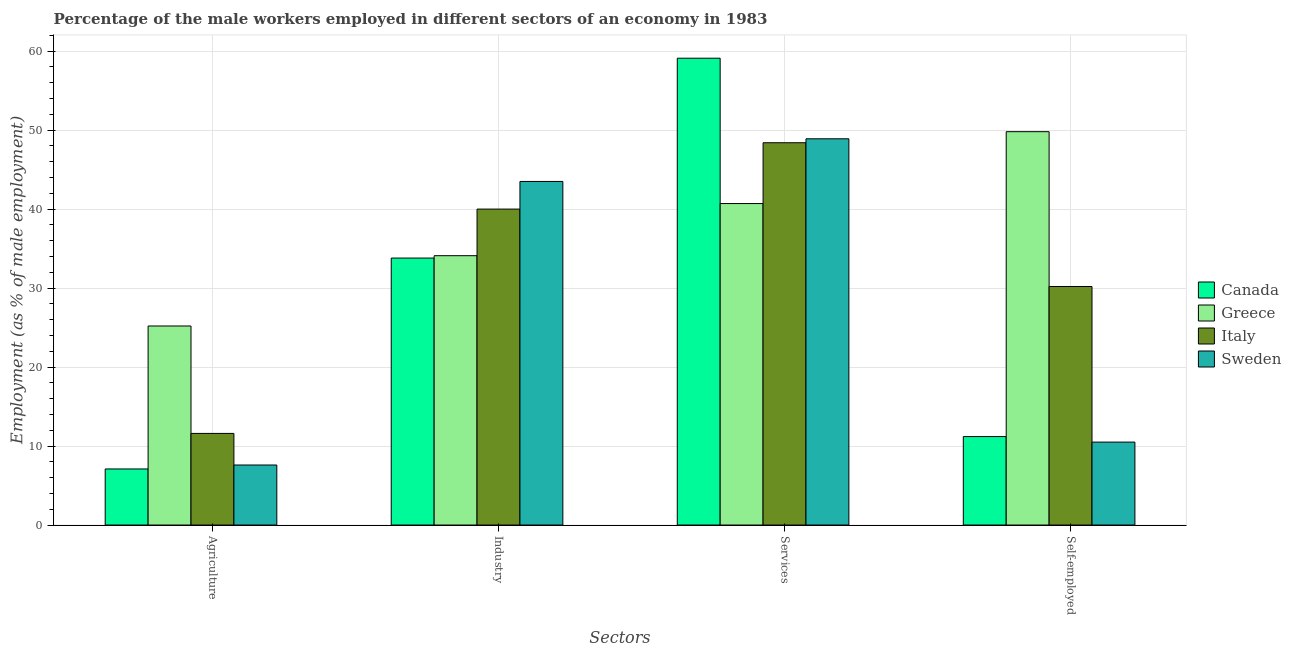How many different coloured bars are there?
Keep it short and to the point. 4. How many groups of bars are there?
Your answer should be very brief. 4. Are the number of bars per tick equal to the number of legend labels?
Offer a terse response. Yes. Are the number of bars on each tick of the X-axis equal?
Make the answer very short. Yes. What is the label of the 4th group of bars from the left?
Provide a succinct answer. Self-employed. What is the percentage of self employed male workers in Canada?
Keep it short and to the point. 11.2. Across all countries, what is the maximum percentage of male workers in agriculture?
Provide a short and direct response. 25.2. Across all countries, what is the minimum percentage of self employed male workers?
Your answer should be very brief. 10.5. In which country was the percentage of male workers in agriculture maximum?
Your response must be concise. Greece. In which country was the percentage of male workers in services minimum?
Offer a terse response. Greece. What is the total percentage of male workers in services in the graph?
Provide a succinct answer. 197.1. What is the difference between the percentage of male workers in industry in Sweden and that in Greece?
Make the answer very short. 9.4. What is the difference between the percentage of male workers in services in Canada and the percentage of male workers in industry in Italy?
Offer a terse response. 19.1. What is the average percentage of male workers in industry per country?
Your answer should be compact. 37.85. What is the difference between the percentage of male workers in industry and percentage of male workers in services in Sweden?
Ensure brevity in your answer.  -5.4. In how many countries, is the percentage of male workers in industry greater than 60 %?
Make the answer very short. 0. What is the ratio of the percentage of male workers in industry in Italy to that in Greece?
Offer a very short reply. 1.17. Is the percentage of male workers in industry in Italy less than that in Canada?
Your answer should be compact. No. Is the difference between the percentage of male workers in industry in Canada and Sweden greater than the difference between the percentage of self employed male workers in Canada and Sweden?
Give a very brief answer. No. What is the difference between the highest and the second highest percentage of self employed male workers?
Ensure brevity in your answer.  19.6. What is the difference between the highest and the lowest percentage of male workers in agriculture?
Offer a terse response. 18.1. In how many countries, is the percentage of self employed male workers greater than the average percentage of self employed male workers taken over all countries?
Offer a very short reply. 2. Is the sum of the percentage of male workers in services in Italy and Sweden greater than the maximum percentage of male workers in agriculture across all countries?
Keep it short and to the point. Yes. Is it the case that in every country, the sum of the percentage of male workers in industry and percentage of self employed male workers is greater than the sum of percentage of male workers in services and percentage of male workers in agriculture?
Your answer should be compact. Yes. Are all the bars in the graph horizontal?
Offer a terse response. No. How many countries are there in the graph?
Your answer should be compact. 4. Does the graph contain any zero values?
Your answer should be very brief. No. Does the graph contain grids?
Your answer should be compact. Yes. How many legend labels are there?
Ensure brevity in your answer.  4. What is the title of the graph?
Ensure brevity in your answer.  Percentage of the male workers employed in different sectors of an economy in 1983. Does "Maldives" appear as one of the legend labels in the graph?
Provide a short and direct response. No. What is the label or title of the X-axis?
Provide a short and direct response. Sectors. What is the label or title of the Y-axis?
Ensure brevity in your answer.  Employment (as % of male employment). What is the Employment (as % of male employment) in Canada in Agriculture?
Keep it short and to the point. 7.1. What is the Employment (as % of male employment) of Greece in Agriculture?
Provide a short and direct response. 25.2. What is the Employment (as % of male employment) in Italy in Agriculture?
Make the answer very short. 11.6. What is the Employment (as % of male employment) of Sweden in Agriculture?
Provide a short and direct response. 7.6. What is the Employment (as % of male employment) of Canada in Industry?
Your response must be concise. 33.8. What is the Employment (as % of male employment) of Greece in Industry?
Offer a very short reply. 34.1. What is the Employment (as % of male employment) in Sweden in Industry?
Your answer should be compact. 43.5. What is the Employment (as % of male employment) of Canada in Services?
Your response must be concise. 59.1. What is the Employment (as % of male employment) in Greece in Services?
Make the answer very short. 40.7. What is the Employment (as % of male employment) of Italy in Services?
Provide a short and direct response. 48.4. What is the Employment (as % of male employment) of Sweden in Services?
Offer a terse response. 48.9. What is the Employment (as % of male employment) in Canada in Self-employed?
Ensure brevity in your answer.  11.2. What is the Employment (as % of male employment) in Greece in Self-employed?
Provide a succinct answer. 49.8. What is the Employment (as % of male employment) in Italy in Self-employed?
Your answer should be compact. 30.2. What is the Employment (as % of male employment) of Sweden in Self-employed?
Give a very brief answer. 10.5. Across all Sectors, what is the maximum Employment (as % of male employment) of Canada?
Your response must be concise. 59.1. Across all Sectors, what is the maximum Employment (as % of male employment) in Greece?
Your response must be concise. 49.8. Across all Sectors, what is the maximum Employment (as % of male employment) of Italy?
Your answer should be compact. 48.4. Across all Sectors, what is the maximum Employment (as % of male employment) of Sweden?
Offer a very short reply. 48.9. Across all Sectors, what is the minimum Employment (as % of male employment) of Canada?
Your answer should be compact. 7.1. Across all Sectors, what is the minimum Employment (as % of male employment) of Greece?
Keep it short and to the point. 25.2. Across all Sectors, what is the minimum Employment (as % of male employment) of Italy?
Give a very brief answer. 11.6. Across all Sectors, what is the minimum Employment (as % of male employment) in Sweden?
Your answer should be very brief. 7.6. What is the total Employment (as % of male employment) of Canada in the graph?
Ensure brevity in your answer.  111.2. What is the total Employment (as % of male employment) of Greece in the graph?
Your answer should be compact. 149.8. What is the total Employment (as % of male employment) in Italy in the graph?
Ensure brevity in your answer.  130.2. What is the total Employment (as % of male employment) of Sweden in the graph?
Offer a very short reply. 110.5. What is the difference between the Employment (as % of male employment) of Canada in Agriculture and that in Industry?
Your response must be concise. -26.7. What is the difference between the Employment (as % of male employment) in Italy in Agriculture and that in Industry?
Make the answer very short. -28.4. What is the difference between the Employment (as % of male employment) in Sweden in Agriculture and that in Industry?
Your answer should be compact. -35.9. What is the difference between the Employment (as % of male employment) in Canada in Agriculture and that in Services?
Provide a short and direct response. -52. What is the difference between the Employment (as % of male employment) in Greece in Agriculture and that in Services?
Ensure brevity in your answer.  -15.5. What is the difference between the Employment (as % of male employment) in Italy in Agriculture and that in Services?
Your answer should be very brief. -36.8. What is the difference between the Employment (as % of male employment) of Sweden in Agriculture and that in Services?
Your answer should be compact. -41.3. What is the difference between the Employment (as % of male employment) of Greece in Agriculture and that in Self-employed?
Keep it short and to the point. -24.6. What is the difference between the Employment (as % of male employment) of Italy in Agriculture and that in Self-employed?
Your answer should be very brief. -18.6. What is the difference between the Employment (as % of male employment) in Canada in Industry and that in Services?
Your response must be concise. -25.3. What is the difference between the Employment (as % of male employment) in Greece in Industry and that in Services?
Provide a short and direct response. -6.6. What is the difference between the Employment (as % of male employment) in Canada in Industry and that in Self-employed?
Give a very brief answer. 22.6. What is the difference between the Employment (as % of male employment) of Greece in Industry and that in Self-employed?
Your response must be concise. -15.7. What is the difference between the Employment (as % of male employment) of Italy in Industry and that in Self-employed?
Ensure brevity in your answer.  9.8. What is the difference between the Employment (as % of male employment) in Sweden in Industry and that in Self-employed?
Your response must be concise. 33. What is the difference between the Employment (as % of male employment) in Canada in Services and that in Self-employed?
Offer a very short reply. 47.9. What is the difference between the Employment (as % of male employment) of Italy in Services and that in Self-employed?
Make the answer very short. 18.2. What is the difference between the Employment (as % of male employment) in Sweden in Services and that in Self-employed?
Keep it short and to the point. 38.4. What is the difference between the Employment (as % of male employment) of Canada in Agriculture and the Employment (as % of male employment) of Italy in Industry?
Ensure brevity in your answer.  -32.9. What is the difference between the Employment (as % of male employment) of Canada in Agriculture and the Employment (as % of male employment) of Sweden in Industry?
Provide a succinct answer. -36.4. What is the difference between the Employment (as % of male employment) in Greece in Agriculture and the Employment (as % of male employment) in Italy in Industry?
Ensure brevity in your answer.  -14.8. What is the difference between the Employment (as % of male employment) in Greece in Agriculture and the Employment (as % of male employment) in Sweden in Industry?
Provide a succinct answer. -18.3. What is the difference between the Employment (as % of male employment) in Italy in Agriculture and the Employment (as % of male employment) in Sweden in Industry?
Your response must be concise. -31.9. What is the difference between the Employment (as % of male employment) of Canada in Agriculture and the Employment (as % of male employment) of Greece in Services?
Offer a very short reply. -33.6. What is the difference between the Employment (as % of male employment) of Canada in Agriculture and the Employment (as % of male employment) of Italy in Services?
Offer a very short reply. -41.3. What is the difference between the Employment (as % of male employment) of Canada in Agriculture and the Employment (as % of male employment) of Sweden in Services?
Offer a terse response. -41.8. What is the difference between the Employment (as % of male employment) in Greece in Agriculture and the Employment (as % of male employment) in Italy in Services?
Your response must be concise. -23.2. What is the difference between the Employment (as % of male employment) in Greece in Agriculture and the Employment (as % of male employment) in Sweden in Services?
Your answer should be very brief. -23.7. What is the difference between the Employment (as % of male employment) of Italy in Agriculture and the Employment (as % of male employment) of Sweden in Services?
Offer a very short reply. -37.3. What is the difference between the Employment (as % of male employment) of Canada in Agriculture and the Employment (as % of male employment) of Greece in Self-employed?
Offer a very short reply. -42.7. What is the difference between the Employment (as % of male employment) in Canada in Agriculture and the Employment (as % of male employment) in Italy in Self-employed?
Ensure brevity in your answer.  -23.1. What is the difference between the Employment (as % of male employment) of Canada in Industry and the Employment (as % of male employment) of Greece in Services?
Your answer should be compact. -6.9. What is the difference between the Employment (as % of male employment) in Canada in Industry and the Employment (as % of male employment) in Italy in Services?
Keep it short and to the point. -14.6. What is the difference between the Employment (as % of male employment) of Canada in Industry and the Employment (as % of male employment) of Sweden in Services?
Keep it short and to the point. -15.1. What is the difference between the Employment (as % of male employment) of Greece in Industry and the Employment (as % of male employment) of Italy in Services?
Keep it short and to the point. -14.3. What is the difference between the Employment (as % of male employment) in Greece in Industry and the Employment (as % of male employment) in Sweden in Services?
Your answer should be compact. -14.8. What is the difference between the Employment (as % of male employment) in Italy in Industry and the Employment (as % of male employment) in Sweden in Services?
Offer a terse response. -8.9. What is the difference between the Employment (as % of male employment) in Canada in Industry and the Employment (as % of male employment) in Greece in Self-employed?
Offer a terse response. -16. What is the difference between the Employment (as % of male employment) in Canada in Industry and the Employment (as % of male employment) in Sweden in Self-employed?
Your response must be concise. 23.3. What is the difference between the Employment (as % of male employment) of Greece in Industry and the Employment (as % of male employment) of Italy in Self-employed?
Give a very brief answer. 3.9. What is the difference between the Employment (as % of male employment) of Greece in Industry and the Employment (as % of male employment) of Sweden in Self-employed?
Keep it short and to the point. 23.6. What is the difference between the Employment (as % of male employment) of Italy in Industry and the Employment (as % of male employment) of Sweden in Self-employed?
Your answer should be compact. 29.5. What is the difference between the Employment (as % of male employment) of Canada in Services and the Employment (as % of male employment) of Italy in Self-employed?
Keep it short and to the point. 28.9. What is the difference between the Employment (as % of male employment) in Canada in Services and the Employment (as % of male employment) in Sweden in Self-employed?
Give a very brief answer. 48.6. What is the difference between the Employment (as % of male employment) of Greece in Services and the Employment (as % of male employment) of Italy in Self-employed?
Ensure brevity in your answer.  10.5. What is the difference between the Employment (as % of male employment) in Greece in Services and the Employment (as % of male employment) in Sweden in Self-employed?
Keep it short and to the point. 30.2. What is the difference between the Employment (as % of male employment) in Italy in Services and the Employment (as % of male employment) in Sweden in Self-employed?
Keep it short and to the point. 37.9. What is the average Employment (as % of male employment) in Canada per Sectors?
Offer a very short reply. 27.8. What is the average Employment (as % of male employment) of Greece per Sectors?
Give a very brief answer. 37.45. What is the average Employment (as % of male employment) in Italy per Sectors?
Provide a short and direct response. 32.55. What is the average Employment (as % of male employment) in Sweden per Sectors?
Keep it short and to the point. 27.62. What is the difference between the Employment (as % of male employment) in Canada and Employment (as % of male employment) in Greece in Agriculture?
Your response must be concise. -18.1. What is the difference between the Employment (as % of male employment) in Canada and Employment (as % of male employment) in Italy in Agriculture?
Your answer should be very brief. -4.5. What is the difference between the Employment (as % of male employment) of Canada and Employment (as % of male employment) of Sweden in Agriculture?
Keep it short and to the point. -0.5. What is the difference between the Employment (as % of male employment) in Greece and Employment (as % of male employment) in Italy in Agriculture?
Your answer should be very brief. 13.6. What is the difference between the Employment (as % of male employment) in Greece and Employment (as % of male employment) in Sweden in Agriculture?
Provide a succinct answer. 17.6. What is the difference between the Employment (as % of male employment) in Canada and Employment (as % of male employment) in Sweden in Industry?
Provide a succinct answer. -9.7. What is the difference between the Employment (as % of male employment) in Greece and Employment (as % of male employment) in Sweden in Industry?
Your answer should be compact. -9.4. What is the difference between the Employment (as % of male employment) of Italy and Employment (as % of male employment) of Sweden in Industry?
Keep it short and to the point. -3.5. What is the difference between the Employment (as % of male employment) in Canada and Employment (as % of male employment) in Italy in Services?
Your response must be concise. 10.7. What is the difference between the Employment (as % of male employment) in Greece and Employment (as % of male employment) in Italy in Services?
Provide a short and direct response. -7.7. What is the difference between the Employment (as % of male employment) of Greece and Employment (as % of male employment) of Sweden in Services?
Offer a terse response. -8.2. What is the difference between the Employment (as % of male employment) in Italy and Employment (as % of male employment) in Sweden in Services?
Ensure brevity in your answer.  -0.5. What is the difference between the Employment (as % of male employment) of Canada and Employment (as % of male employment) of Greece in Self-employed?
Provide a succinct answer. -38.6. What is the difference between the Employment (as % of male employment) of Greece and Employment (as % of male employment) of Italy in Self-employed?
Provide a succinct answer. 19.6. What is the difference between the Employment (as % of male employment) in Greece and Employment (as % of male employment) in Sweden in Self-employed?
Provide a short and direct response. 39.3. What is the ratio of the Employment (as % of male employment) of Canada in Agriculture to that in Industry?
Make the answer very short. 0.21. What is the ratio of the Employment (as % of male employment) of Greece in Agriculture to that in Industry?
Provide a succinct answer. 0.74. What is the ratio of the Employment (as % of male employment) in Italy in Agriculture to that in Industry?
Provide a short and direct response. 0.29. What is the ratio of the Employment (as % of male employment) of Sweden in Agriculture to that in Industry?
Give a very brief answer. 0.17. What is the ratio of the Employment (as % of male employment) of Canada in Agriculture to that in Services?
Ensure brevity in your answer.  0.12. What is the ratio of the Employment (as % of male employment) in Greece in Agriculture to that in Services?
Make the answer very short. 0.62. What is the ratio of the Employment (as % of male employment) of Italy in Agriculture to that in Services?
Make the answer very short. 0.24. What is the ratio of the Employment (as % of male employment) of Sweden in Agriculture to that in Services?
Offer a very short reply. 0.16. What is the ratio of the Employment (as % of male employment) of Canada in Agriculture to that in Self-employed?
Offer a terse response. 0.63. What is the ratio of the Employment (as % of male employment) in Greece in Agriculture to that in Self-employed?
Your response must be concise. 0.51. What is the ratio of the Employment (as % of male employment) in Italy in Agriculture to that in Self-employed?
Your answer should be very brief. 0.38. What is the ratio of the Employment (as % of male employment) of Sweden in Agriculture to that in Self-employed?
Offer a terse response. 0.72. What is the ratio of the Employment (as % of male employment) of Canada in Industry to that in Services?
Provide a short and direct response. 0.57. What is the ratio of the Employment (as % of male employment) in Greece in Industry to that in Services?
Offer a terse response. 0.84. What is the ratio of the Employment (as % of male employment) in Italy in Industry to that in Services?
Your response must be concise. 0.83. What is the ratio of the Employment (as % of male employment) of Sweden in Industry to that in Services?
Offer a very short reply. 0.89. What is the ratio of the Employment (as % of male employment) of Canada in Industry to that in Self-employed?
Your answer should be compact. 3.02. What is the ratio of the Employment (as % of male employment) in Greece in Industry to that in Self-employed?
Provide a succinct answer. 0.68. What is the ratio of the Employment (as % of male employment) of Italy in Industry to that in Self-employed?
Make the answer very short. 1.32. What is the ratio of the Employment (as % of male employment) in Sweden in Industry to that in Self-employed?
Provide a short and direct response. 4.14. What is the ratio of the Employment (as % of male employment) in Canada in Services to that in Self-employed?
Your answer should be very brief. 5.28. What is the ratio of the Employment (as % of male employment) of Greece in Services to that in Self-employed?
Provide a short and direct response. 0.82. What is the ratio of the Employment (as % of male employment) of Italy in Services to that in Self-employed?
Keep it short and to the point. 1.6. What is the ratio of the Employment (as % of male employment) in Sweden in Services to that in Self-employed?
Your answer should be very brief. 4.66. What is the difference between the highest and the second highest Employment (as % of male employment) in Canada?
Your response must be concise. 25.3. What is the difference between the highest and the second highest Employment (as % of male employment) of Greece?
Your answer should be compact. 9.1. What is the difference between the highest and the second highest Employment (as % of male employment) in Italy?
Ensure brevity in your answer.  8.4. What is the difference between the highest and the lowest Employment (as % of male employment) of Canada?
Provide a short and direct response. 52. What is the difference between the highest and the lowest Employment (as % of male employment) in Greece?
Provide a short and direct response. 24.6. What is the difference between the highest and the lowest Employment (as % of male employment) of Italy?
Ensure brevity in your answer.  36.8. What is the difference between the highest and the lowest Employment (as % of male employment) in Sweden?
Give a very brief answer. 41.3. 